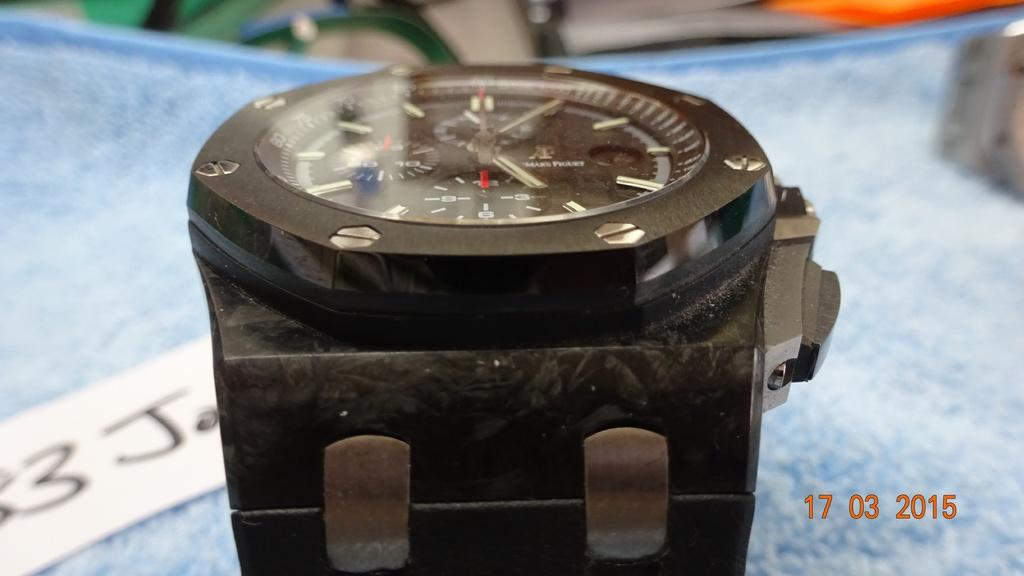<image>
Provide a brief description of the given image. Face of a watch on top of a white piece of paper which says 3J on it. 